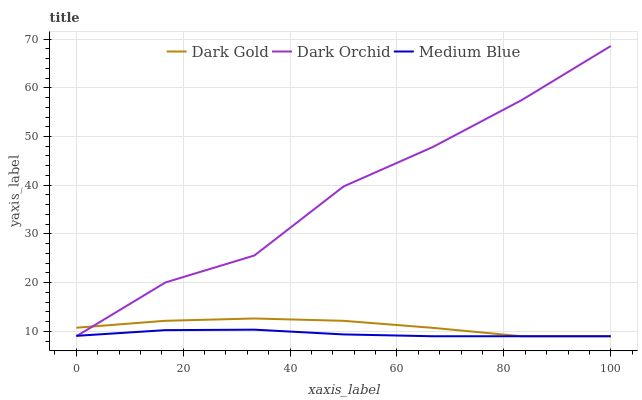Does Medium Blue have the minimum area under the curve?
Answer yes or no. Yes. Does Dark Orchid have the maximum area under the curve?
Answer yes or no. Yes. Does Dark Gold have the minimum area under the curve?
Answer yes or no. No. Does Dark Gold have the maximum area under the curve?
Answer yes or no. No. Is Medium Blue the smoothest?
Answer yes or no. Yes. Is Dark Orchid the roughest?
Answer yes or no. Yes. Is Dark Gold the smoothest?
Answer yes or no. No. Is Dark Gold the roughest?
Answer yes or no. No. Does Medium Blue have the lowest value?
Answer yes or no. Yes. Does Dark Orchid have the highest value?
Answer yes or no. Yes. Does Dark Gold have the highest value?
Answer yes or no. No. Does Dark Orchid intersect Medium Blue?
Answer yes or no. Yes. Is Dark Orchid less than Medium Blue?
Answer yes or no. No. Is Dark Orchid greater than Medium Blue?
Answer yes or no. No. 